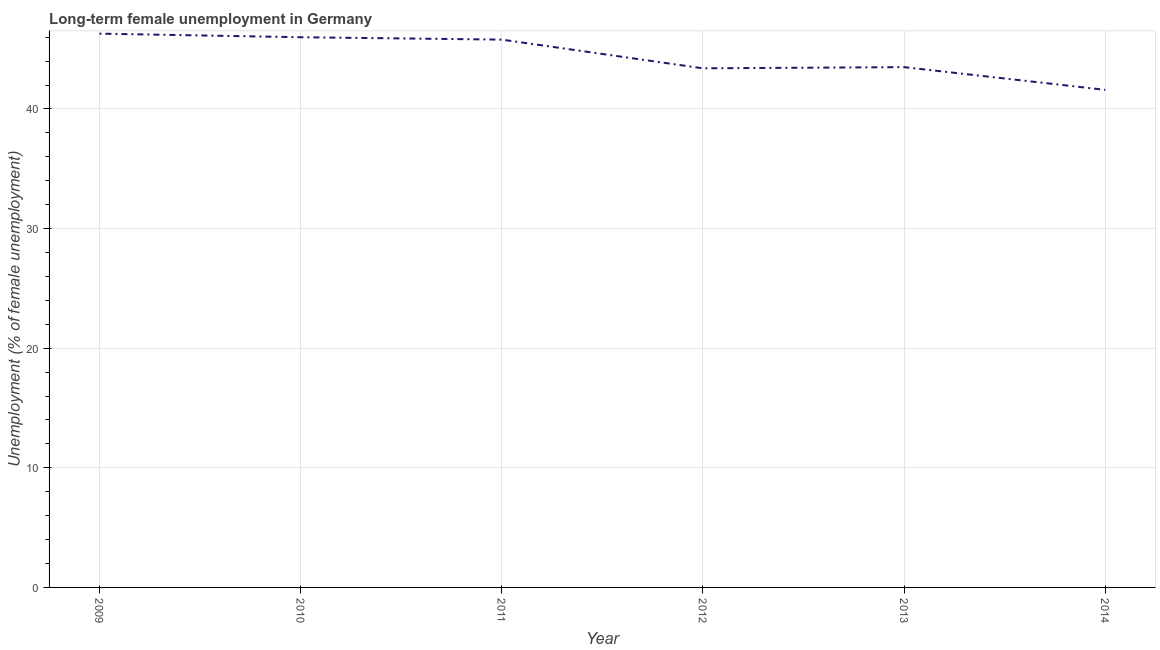What is the long-term female unemployment in 2012?
Your response must be concise. 43.4. Across all years, what is the maximum long-term female unemployment?
Ensure brevity in your answer.  46.3. Across all years, what is the minimum long-term female unemployment?
Your answer should be compact. 41.6. What is the sum of the long-term female unemployment?
Your answer should be compact. 266.6. What is the difference between the long-term female unemployment in 2010 and 2012?
Your answer should be compact. 2.6. What is the average long-term female unemployment per year?
Your answer should be very brief. 44.43. What is the median long-term female unemployment?
Ensure brevity in your answer.  44.65. Do a majority of the years between 2013 and 2014 (inclusive) have long-term female unemployment greater than 30 %?
Your response must be concise. Yes. What is the ratio of the long-term female unemployment in 2010 to that in 2011?
Provide a succinct answer. 1. Is the long-term female unemployment in 2009 less than that in 2013?
Your response must be concise. No. Is the difference between the long-term female unemployment in 2011 and 2012 greater than the difference between any two years?
Offer a terse response. No. What is the difference between the highest and the second highest long-term female unemployment?
Provide a short and direct response. 0.3. Is the sum of the long-term female unemployment in 2010 and 2014 greater than the maximum long-term female unemployment across all years?
Make the answer very short. Yes. What is the difference between the highest and the lowest long-term female unemployment?
Your answer should be compact. 4.7. In how many years, is the long-term female unemployment greater than the average long-term female unemployment taken over all years?
Make the answer very short. 3. What is the difference between two consecutive major ticks on the Y-axis?
Give a very brief answer. 10. Are the values on the major ticks of Y-axis written in scientific E-notation?
Provide a succinct answer. No. What is the title of the graph?
Make the answer very short. Long-term female unemployment in Germany. What is the label or title of the X-axis?
Keep it short and to the point. Year. What is the label or title of the Y-axis?
Ensure brevity in your answer.  Unemployment (% of female unemployment). What is the Unemployment (% of female unemployment) in 2009?
Offer a very short reply. 46.3. What is the Unemployment (% of female unemployment) in 2010?
Keep it short and to the point. 46. What is the Unemployment (% of female unemployment) of 2011?
Ensure brevity in your answer.  45.8. What is the Unemployment (% of female unemployment) in 2012?
Your answer should be compact. 43.4. What is the Unemployment (% of female unemployment) of 2013?
Ensure brevity in your answer.  43.5. What is the Unemployment (% of female unemployment) in 2014?
Ensure brevity in your answer.  41.6. What is the difference between the Unemployment (% of female unemployment) in 2009 and 2012?
Offer a terse response. 2.9. What is the difference between the Unemployment (% of female unemployment) in 2009 and 2013?
Make the answer very short. 2.8. What is the difference between the Unemployment (% of female unemployment) in 2010 and 2011?
Your answer should be very brief. 0.2. What is the difference between the Unemployment (% of female unemployment) in 2010 and 2012?
Provide a short and direct response. 2.6. What is the difference between the Unemployment (% of female unemployment) in 2010 and 2013?
Your response must be concise. 2.5. What is the difference between the Unemployment (% of female unemployment) in 2010 and 2014?
Give a very brief answer. 4.4. What is the difference between the Unemployment (% of female unemployment) in 2011 and 2012?
Make the answer very short. 2.4. What is the difference between the Unemployment (% of female unemployment) in 2013 and 2014?
Make the answer very short. 1.9. What is the ratio of the Unemployment (% of female unemployment) in 2009 to that in 2010?
Your answer should be very brief. 1.01. What is the ratio of the Unemployment (% of female unemployment) in 2009 to that in 2011?
Provide a short and direct response. 1.01. What is the ratio of the Unemployment (% of female unemployment) in 2009 to that in 2012?
Make the answer very short. 1.07. What is the ratio of the Unemployment (% of female unemployment) in 2009 to that in 2013?
Your answer should be compact. 1.06. What is the ratio of the Unemployment (% of female unemployment) in 2009 to that in 2014?
Your answer should be very brief. 1.11. What is the ratio of the Unemployment (% of female unemployment) in 2010 to that in 2012?
Your answer should be very brief. 1.06. What is the ratio of the Unemployment (% of female unemployment) in 2010 to that in 2013?
Provide a succinct answer. 1.06. What is the ratio of the Unemployment (% of female unemployment) in 2010 to that in 2014?
Provide a short and direct response. 1.11. What is the ratio of the Unemployment (% of female unemployment) in 2011 to that in 2012?
Ensure brevity in your answer.  1.05. What is the ratio of the Unemployment (% of female unemployment) in 2011 to that in 2013?
Make the answer very short. 1.05. What is the ratio of the Unemployment (% of female unemployment) in 2011 to that in 2014?
Give a very brief answer. 1.1. What is the ratio of the Unemployment (% of female unemployment) in 2012 to that in 2013?
Provide a succinct answer. 1. What is the ratio of the Unemployment (% of female unemployment) in 2012 to that in 2014?
Make the answer very short. 1.04. What is the ratio of the Unemployment (% of female unemployment) in 2013 to that in 2014?
Ensure brevity in your answer.  1.05. 